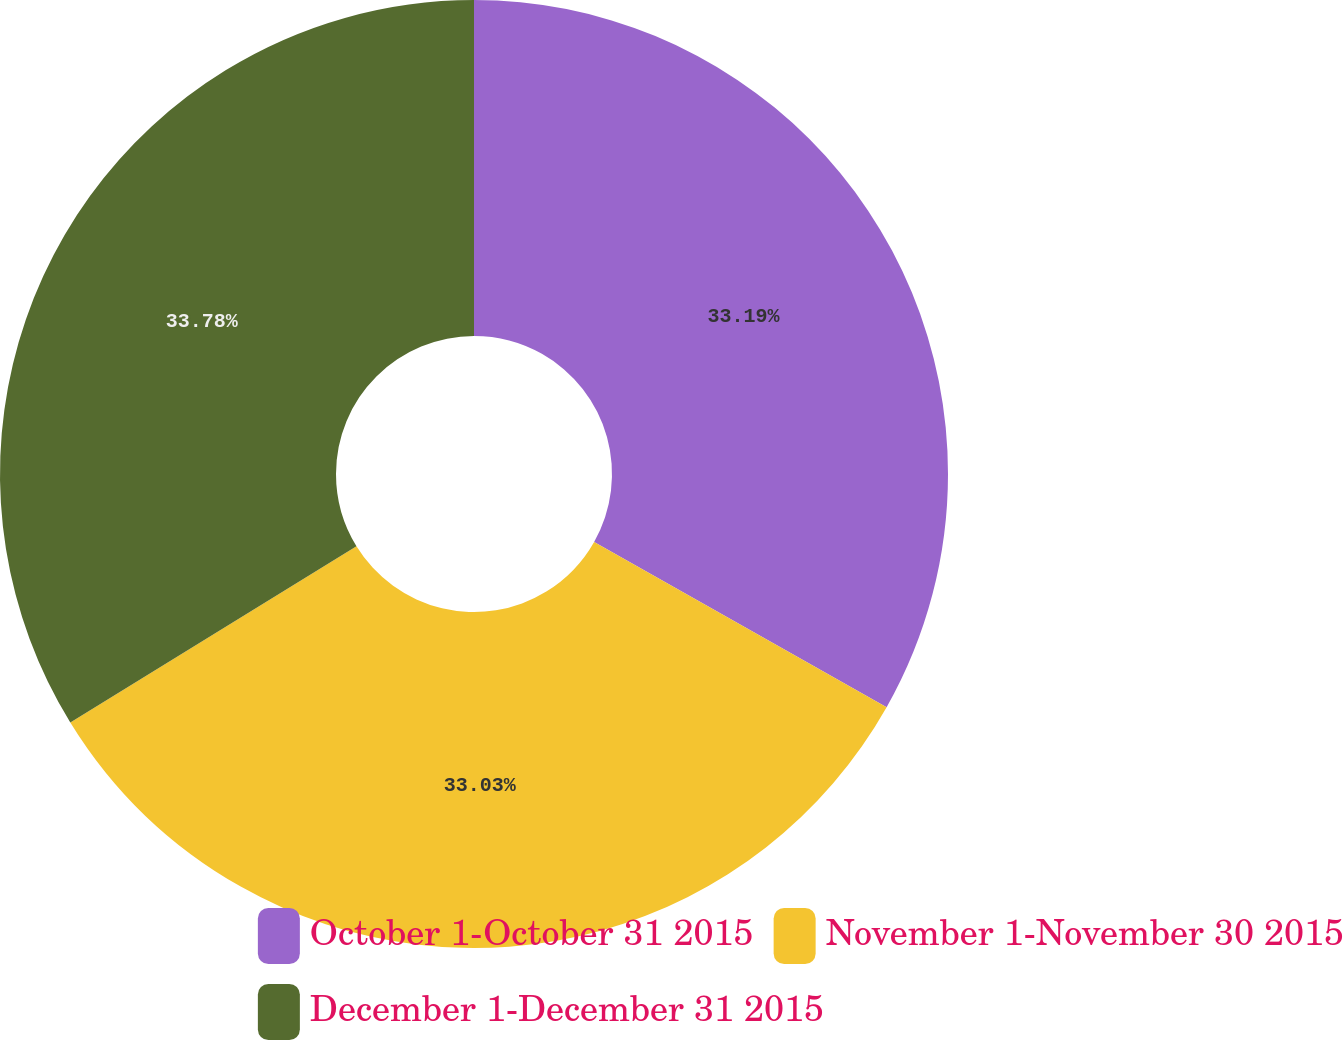Convert chart to OTSL. <chart><loc_0><loc_0><loc_500><loc_500><pie_chart><fcel>October 1-October 31 2015<fcel>November 1-November 30 2015<fcel>December 1-December 31 2015<nl><fcel>33.19%<fcel>33.03%<fcel>33.78%<nl></chart> 